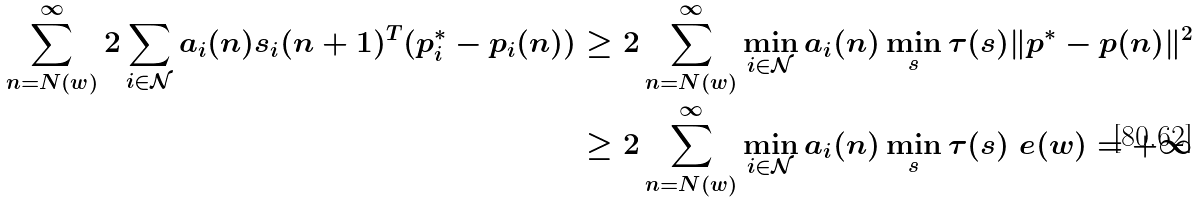Convert formula to latex. <formula><loc_0><loc_0><loc_500><loc_500>\sum _ { n = N ( w ) } ^ { \infty } 2 \sum _ { i \in \mathcal { N } } a _ { i } ( n ) s _ { i } ( n + 1 ) ^ { T } ( p ^ { * } _ { i } - p _ { i } ( n ) ) & \geq 2 \sum _ { n = N ( w ) } ^ { \infty } \min _ { i \in \mathcal { N } } a _ { i } ( n ) \min _ { s } \tau ( s ) \| p ^ { * } - p ( n ) \| ^ { 2 } \\ & \geq 2 \sum _ { n = N ( w ) } ^ { \infty } \min _ { i \in \mathcal { N } } a _ { i } ( n ) \min _ { s } \tau ( s ) \ e ( w ) = + \infty</formula> 